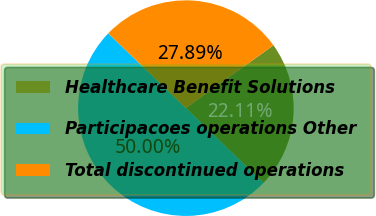Convert chart to OTSL. <chart><loc_0><loc_0><loc_500><loc_500><pie_chart><fcel>Healthcare Benefit Solutions<fcel>Participacoes operations Other<fcel>Total discontinued operations<nl><fcel>22.11%<fcel>50.0%<fcel>27.89%<nl></chart> 